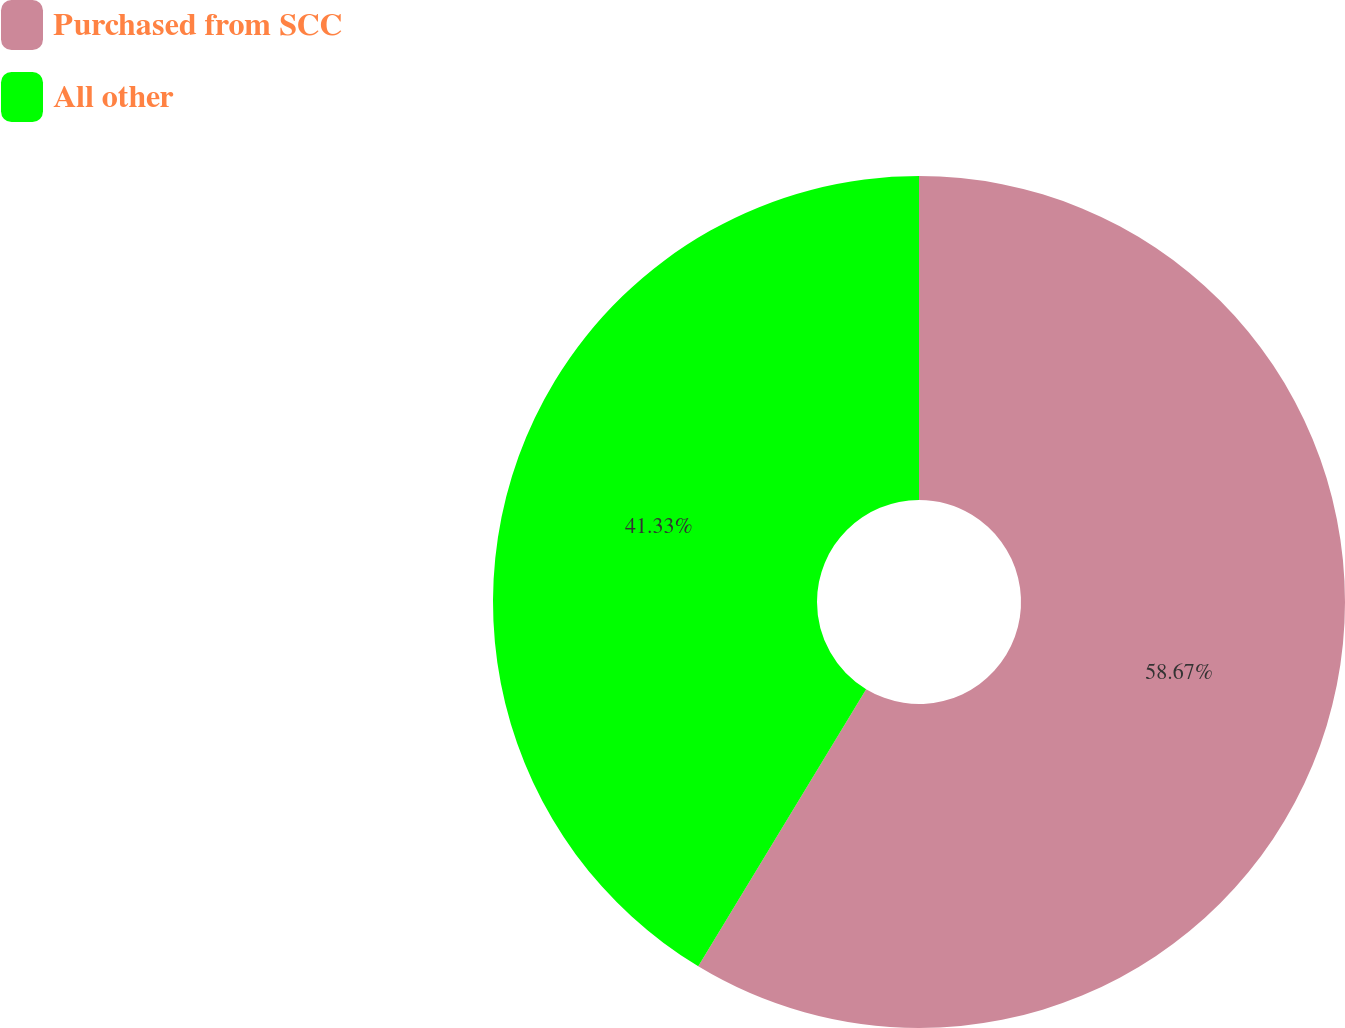Convert chart to OTSL. <chart><loc_0><loc_0><loc_500><loc_500><pie_chart><fcel>Purchased from SCC<fcel>All other<nl><fcel>58.67%<fcel>41.33%<nl></chart> 